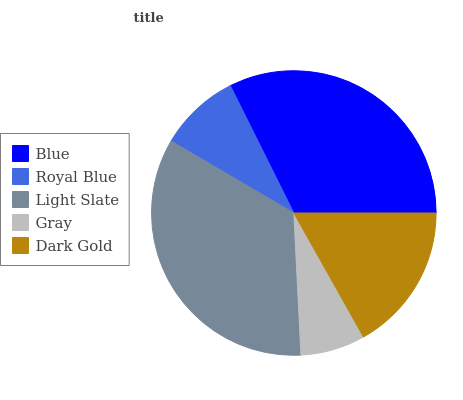Is Gray the minimum?
Answer yes or no. Yes. Is Light Slate the maximum?
Answer yes or no. Yes. Is Royal Blue the minimum?
Answer yes or no. No. Is Royal Blue the maximum?
Answer yes or no. No. Is Blue greater than Royal Blue?
Answer yes or no. Yes. Is Royal Blue less than Blue?
Answer yes or no. Yes. Is Royal Blue greater than Blue?
Answer yes or no. No. Is Blue less than Royal Blue?
Answer yes or no. No. Is Dark Gold the high median?
Answer yes or no. Yes. Is Dark Gold the low median?
Answer yes or no. Yes. Is Royal Blue the high median?
Answer yes or no. No. Is Royal Blue the low median?
Answer yes or no. No. 